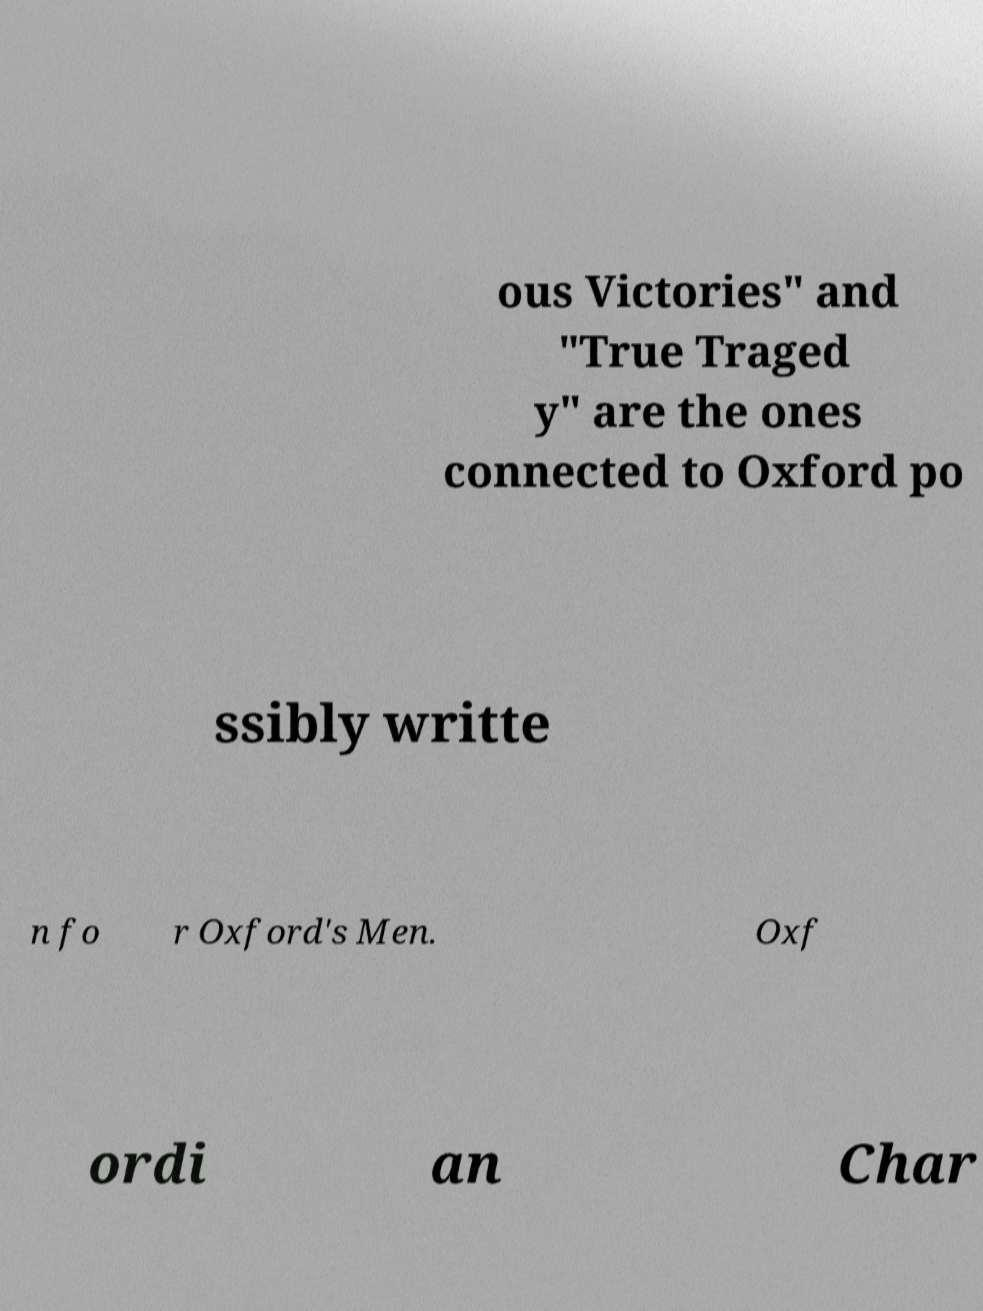For documentation purposes, I need the text within this image transcribed. Could you provide that? ous Victories" and "True Traged y" are the ones connected to Oxford po ssibly writte n fo r Oxford's Men. Oxf ordi an Char 